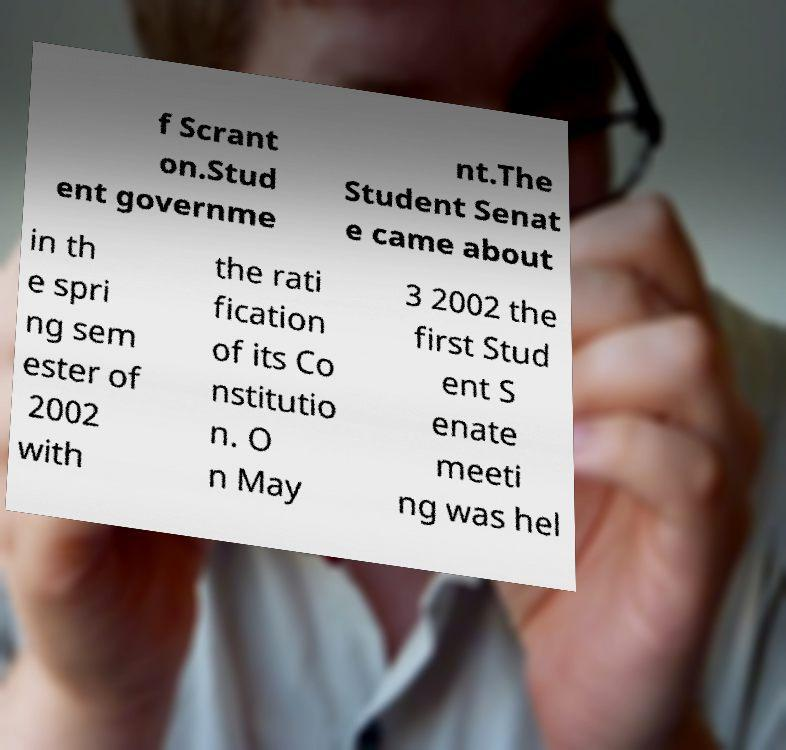I need the written content from this picture converted into text. Can you do that? f Scrant on.Stud ent governme nt.The Student Senat e came about in th e spri ng sem ester of 2002 with the rati fication of its Co nstitutio n. O n May 3 2002 the first Stud ent S enate meeti ng was hel 